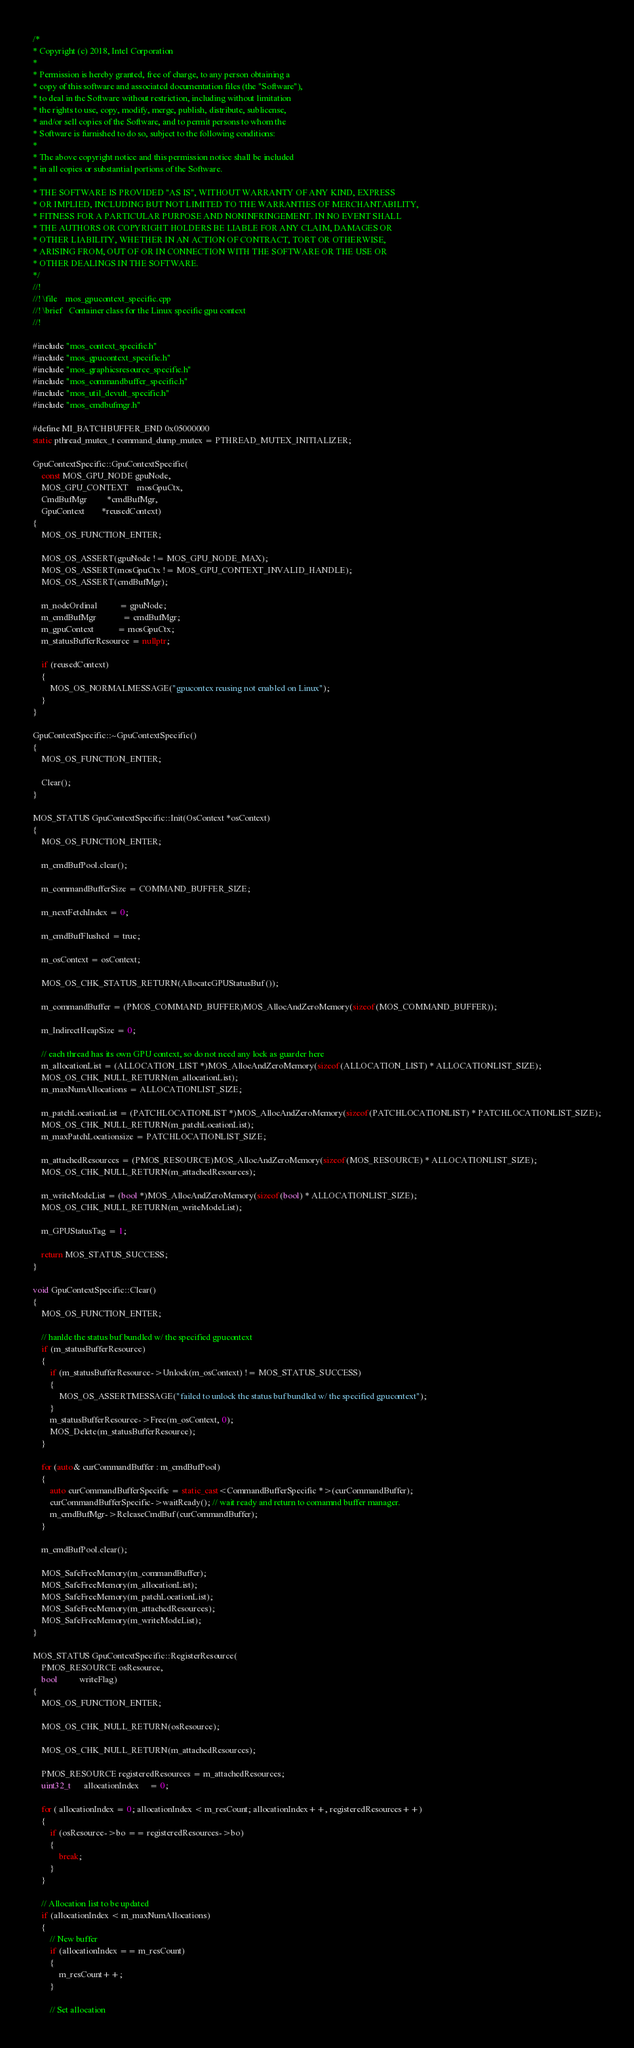<code> <loc_0><loc_0><loc_500><loc_500><_C++_>/*
* Copyright (c) 2018, Intel Corporation
*
* Permission is hereby granted, free of charge, to any person obtaining a
* copy of this software and associated documentation files (the "Software"),
* to deal in the Software without restriction, including without limitation
* the rights to use, copy, modify, merge, publish, distribute, sublicense,
* and/or sell copies of the Software, and to permit persons to whom the
* Software is furnished to do so, subject to the following conditions:
*
* The above copyright notice and this permission notice shall be included
* in all copies or substantial portions of the Software.
*
* THE SOFTWARE IS PROVIDED "AS IS", WITHOUT WARRANTY OF ANY KIND, EXPRESS
* OR IMPLIED, INCLUDING BUT NOT LIMITED TO THE WARRANTIES OF MERCHANTABILITY,
* FITNESS FOR A PARTICULAR PURPOSE AND NONINFRINGEMENT. IN NO EVENT SHALL
* THE AUTHORS OR COPYRIGHT HOLDERS BE LIABLE FOR ANY CLAIM, DAMAGES OR
* OTHER LIABILITY, WHETHER IN AN ACTION OF CONTRACT, TORT OR OTHERWISE,
* ARISING FROM, OUT OF OR IN CONNECTION WITH THE SOFTWARE OR THE USE OR
* OTHER DEALINGS IN THE SOFTWARE.
*/
//!
//! \file    mos_gpucontext_specific.cpp
//! \brief   Container class for the Linux specific gpu context
//!

#include "mos_context_specific.h"
#include "mos_gpucontext_specific.h"
#include "mos_graphicsresource_specific.h"
#include "mos_commandbuffer_specific.h"
#include "mos_util_devult_specific.h"
#include "mos_cmdbufmgr.h"

#define MI_BATCHBUFFER_END 0x05000000
static pthread_mutex_t command_dump_mutex = PTHREAD_MUTEX_INITIALIZER;

GpuContextSpecific::GpuContextSpecific(
    const MOS_GPU_NODE gpuNode,
    MOS_GPU_CONTEXT    mosGpuCtx,
    CmdBufMgr         *cmdBufMgr,
    GpuContext        *reusedContext)
{
    MOS_OS_FUNCTION_ENTER;

    MOS_OS_ASSERT(gpuNode != MOS_GPU_NODE_MAX);
    MOS_OS_ASSERT(mosGpuCtx != MOS_GPU_CONTEXT_INVALID_HANDLE);
    MOS_OS_ASSERT(cmdBufMgr);

    m_nodeOrdinal          = gpuNode;
    m_cmdBufMgr            = cmdBufMgr;
    m_gpuContext           = mosGpuCtx;
    m_statusBufferResource = nullptr;

    if (reusedContext)
    {
        MOS_OS_NORMALMESSAGE("gpucontex reusing not enabled on Linux");
    }
}

GpuContextSpecific::~GpuContextSpecific()
{
    MOS_OS_FUNCTION_ENTER;

    Clear();
}

MOS_STATUS GpuContextSpecific::Init(OsContext *osContext)
{
    MOS_OS_FUNCTION_ENTER;

    m_cmdBufPool.clear();

    m_commandBufferSize = COMMAND_BUFFER_SIZE;

    m_nextFetchIndex = 0;

    m_cmdBufFlushed = true;

    m_osContext = osContext;

    MOS_OS_CHK_STATUS_RETURN(AllocateGPUStatusBuf());

    m_commandBuffer = (PMOS_COMMAND_BUFFER)MOS_AllocAndZeroMemory(sizeof(MOS_COMMAND_BUFFER));

    m_IndirectHeapSize = 0;

    // each thread has its own GPU context, so do not need any lock as guarder here
    m_allocationList = (ALLOCATION_LIST *)MOS_AllocAndZeroMemory(sizeof(ALLOCATION_LIST) * ALLOCATIONLIST_SIZE);
    MOS_OS_CHK_NULL_RETURN(m_allocationList);
    m_maxNumAllocations = ALLOCATIONLIST_SIZE;

    m_patchLocationList = (PATCHLOCATIONLIST *)MOS_AllocAndZeroMemory(sizeof(PATCHLOCATIONLIST) * PATCHLOCATIONLIST_SIZE);
    MOS_OS_CHK_NULL_RETURN(m_patchLocationList);
    m_maxPatchLocationsize = PATCHLOCATIONLIST_SIZE;

    m_attachedResources = (PMOS_RESOURCE)MOS_AllocAndZeroMemory(sizeof(MOS_RESOURCE) * ALLOCATIONLIST_SIZE);
    MOS_OS_CHK_NULL_RETURN(m_attachedResources);

    m_writeModeList = (bool *)MOS_AllocAndZeroMemory(sizeof(bool) * ALLOCATIONLIST_SIZE);
    MOS_OS_CHK_NULL_RETURN(m_writeModeList);

    m_GPUStatusTag = 1;

    return MOS_STATUS_SUCCESS;
}

void GpuContextSpecific::Clear()
{
    MOS_OS_FUNCTION_ENTER;

    // hanlde the status buf bundled w/ the specified gpucontext
    if (m_statusBufferResource)
    {
        if (m_statusBufferResource->Unlock(m_osContext) != MOS_STATUS_SUCCESS)
        {
            MOS_OS_ASSERTMESSAGE("failed to unlock the status buf bundled w/ the specified gpucontext");
        }
        m_statusBufferResource->Free(m_osContext, 0);
        MOS_Delete(m_statusBufferResource);
    }

    for (auto& curCommandBuffer : m_cmdBufPool)
    {
        auto curCommandBufferSpecific = static_cast<CommandBufferSpecific *>(curCommandBuffer);
        curCommandBufferSpecific->waitReady(); // wait ready and return to comamnd buffer manager.
        m_cmdBufMgr->ReleaseCmdBuf(curCommandBuffer);
    }

    m_cmdBufPool.clear();

    MOS_SafeFreeMemory(m_commandBuffer);
    MOS_SafeFreeMemory(m_allocationList);
    MOS_SafeFreeMemory(m_patchLocationList);
    MOS_SafeFreeMemory(m_attachedResources);
    MOS_SafeFreeMemory(m_writeModeList);
}

MOS_STATUS GpuContextSpecific::RegisterResource(
    PMOS_RESOURCE osResource,
    bool          writeFlag)
{
    MOS_OS_FUNCTION_ENTER;

    MOS_OS_CHK_NULL_RETURN(osResource);

    MOS_OS_CHK_NULL_RETURN(m_attachedResources);

    PMOS_RESOURCE registeredResources = m_attachedResources;
    uint32_t      allocationIndex     = 0;

    for ( allocationIndex = 0; allocationIndex < m_resCount; allocationIndex++, registeredResources++)
    {
        if (osResource->bo == registeredResources->bo)
        {
            break;
        }
    }

    // Allocation list to be updated
    if (allocationIndex < m_maxNumAllocations)
    {
        // New buffer
        if (allocationIndex == m_resCount)
        {
            m_resCount++;
        }

        // Set allocation</code> 